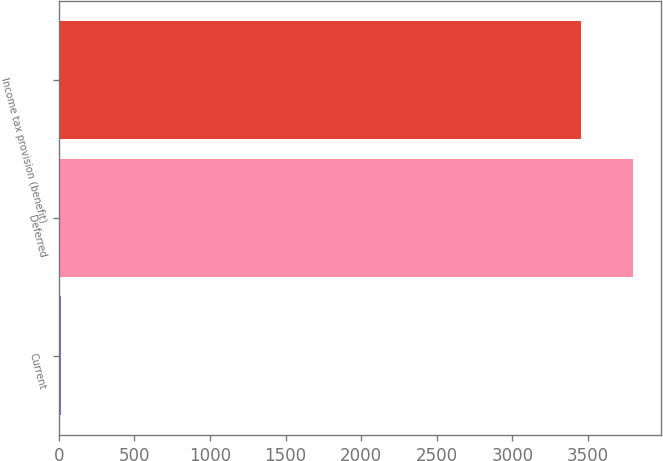Convert chart. <chart><loc_0><loc_0><loc_500><loc_500><bar_chart><fcel>Current<fcel>Deferred<fcel>Income tax provision (benefit)<nl><fcel>15<fcel>3797.2<fcel>3452<nl></chart> 